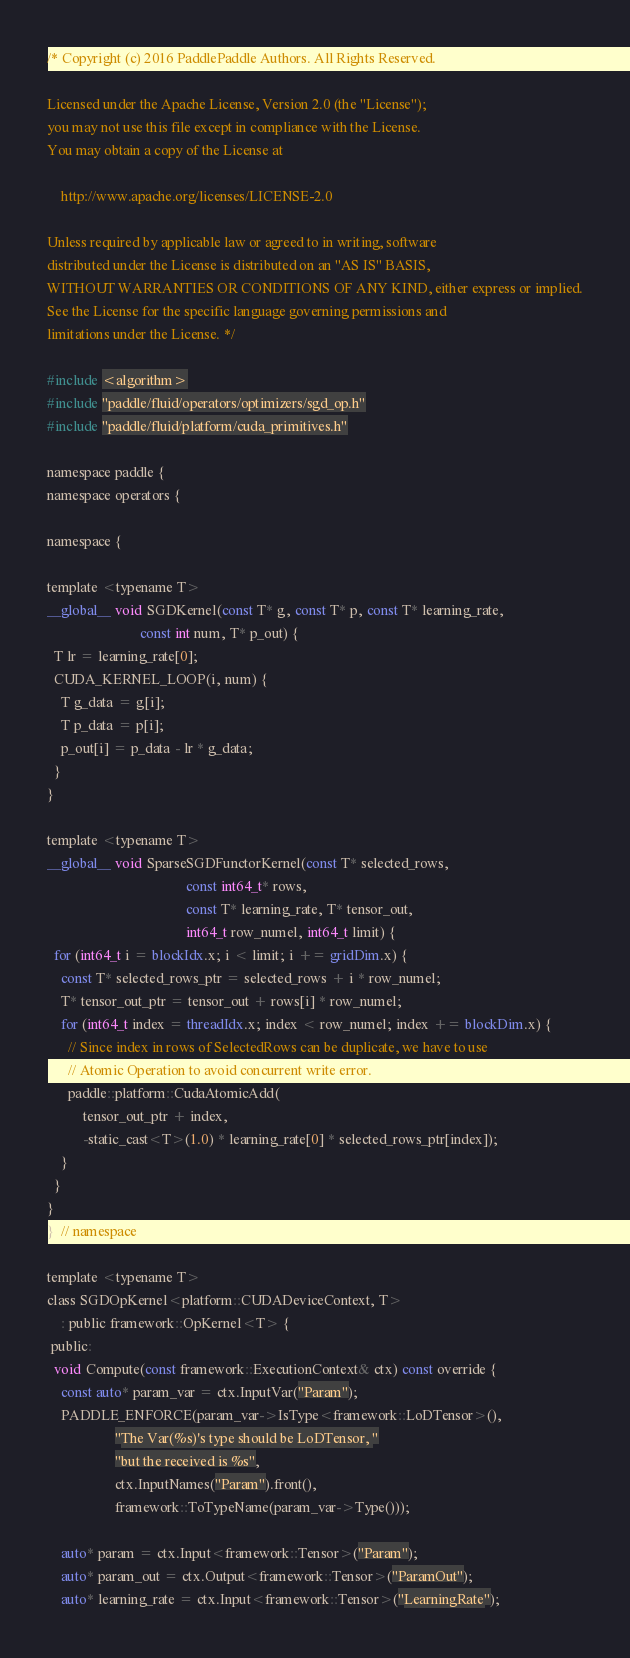Convert code to text. <code><loc_0><loc_0><loc_500><loc_500><_Cuda_>/* Copyright (c) 2016 PaddlePaddle Authors. All Rights Reserved.

Licensed under the Apache License, Version 2.0 (the "License");
you may not use this file except in compliance with the License.
You may obtain a copy of the License at

    http://www.apache.org/licenses/LICENSE-2.0

Unless required by applicable law or agreed to in writing, software
distributed under the License is distributed on an "AS IS" BASIS,
WITHOUT WARRANTIES OR CONDITIONS OF ANY KIND, either express or implied.
See the License for the specific language governing permissions and
limitations under the License. */

#include <algorithm>
#include "paddle/fluid/operators/optimizers/sgd_op.h"
#include "paddle/fluid/platform/cuda_primitives.h"

namespace paddle {
namespace operators {

namespace {

template <typename T>
__global__ void SGDKernel(const T* g, const T* p, const T* learning_rate,
                          const int num, T* p_out) {
  T lr = learning_rate[0];
  CUDA_KERNEL_LOOP(i, num) {
    T g_data = g[i];
    T p_data = p[i];
    p_out[i] = p_data - lr * g_data;
  }
}

template <typename T>
__global__ void SparseSGDFunctorKernel(const T* selected_rows,
                                       const int64_t* rows,
                                       const T* learning_rate, T* tensor_out,
                                       int64_t row_numel, int64_t limit) {
  for (int64_t i = blockIdx.x; i < limit; i += gridDim.x) {
    const T* selected_rows_ptr = selected_rows + i * row_numel;
    T* tensor_out_ptr = tensor_out + rows[i] * row_numel;
    for (int64_t index = threadIdx.x; index < row_numel; index += blockDim.x) {
      // Since index in rows of SelectedRows can be duplicate, we have to use
      // Atomic Operation to avoid concurrent write error.
      paddle::platform::CudaAtomicAdd(
          tensor_out_ptr + index,
          -static_cast<T>(1.0) * learning_rate[0] * selected_rows_ptr[index]);
    }
  }
}
}  // namespace

template <typename T>
class SGDOpKernel<platform::CUDADeviceContext, T>
    : public framework::OpKernel<T> {
 public:
  void Compute(const framework::ExecutionContext& ctx) const override {
    const auto* param_var = ctx.InputVar("Param");
    PADDLE_ENFORCE(param_var->IsType<framework::LoDTensor>(),
                   "The Var(%s)'s type should be LoDTensor, "
                   "but the received is %s",
                   ctx.InputNames("Param").front(),
                   framework::ToTypeName(param_var->Type()));

    auto* param = ctx.Input<framework::Tensor>("Param");
    auto* param_out = ctx.Output<framework::Tensor>("ParamOut");
    auto* learning_rate = ctx.Input<framework::Tensor>("LearningRate");
</code> 